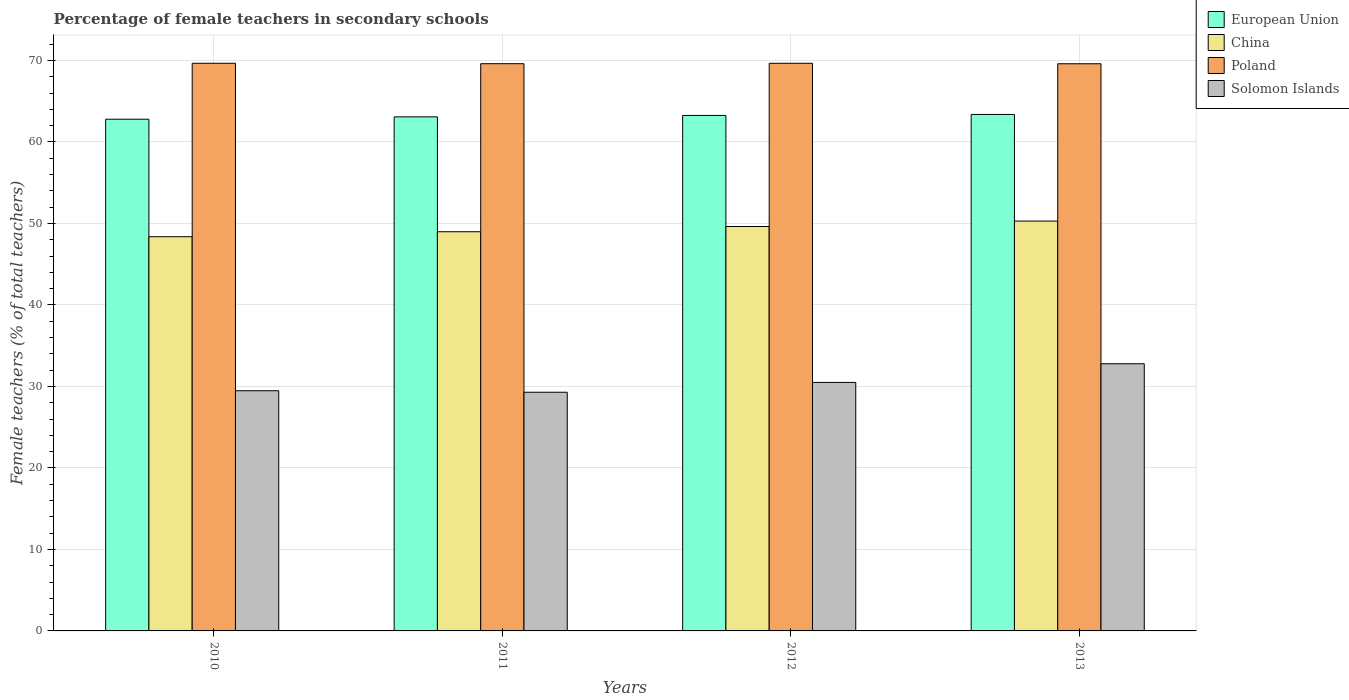How many groups of bars are there?
Give a very brief answer. 4. Are the number of bars per tick equal to the number of legend labels?
Offer a very short reply. Yes. Are the number of bars on each tick of the X-axis equal?
Offer a very short reply. Yes. How many bars are there on the 4th tick from the left?
Your answer should be very brief. 4. How many bars are there on the 2nd tick from the right?
Provide a short and direct response. 4. What is the label of the 3rd group of bars from the left?
Make the answer very short. 2012. In how many cases, is the number of bars for a given year not equal to the number of legend labels?
Your response must be concise. 0. What is the percentage of female teachers in European Union in 2012?
Your response must be concise. 63.25. Across all years, what is the maximum percentage of female teachers in Poland?
Give a very brief answer. 69.65. Across all years, what is the minimum percentage of female teachers in European Union?
Offer a terse response. 62.78. What is the total percentage of female teachers in Solomon Islands in the graph?
Keep it short and to the point. 122.03. What is the difference between the percentage of female teachers in China in 2011 and that in 2012?
Your answer should be compact. -0.64. What is the difference between the percentage of female teachers in Solomon Islands in 2011 and the percentage of female teachers in European Union in 2013?
Provide a short and direct response. -34.08. What is the average percentage of female teachers in European Union per year?
Ensure brevity in your answer.  63.12. In the year 2013, what is the difference between the percentage of female teachers in Poland and percentage of female teachers in Solomon Islands?
Make the answer very short. 36.81. What is the ratio of the percentage of female teachers in European Union in 2011 to that in 2012?
Give a very brief answer. 1. Is the percentage of female teachers in Poland in 2010 less than that in 2011?
Give a very brief answer. No. Is the difference between the percentage of female teachers in Poland in 2010 and 2013 greater than the difference between the percentage of female teachers in Solomon Islands in 2010 and 2013?
Give a very brief answer. Yes. What is the difference between the highest and the second highest percentage of female teachers in Solomon Islands?
Ensure brevity in your answer.  2.29. What is the difference between the highest and the lowest percentage of female teachers in Solomon Islands?
Your response must be concise. 3.5. In how many years, is the percentage of female teachers in China greater than the average percentage of female teachers in China taken over all years?
Keep it short and to the point. 2. What does the 2nd bar from the left in 2010 represents?
Give a very brief answer. China. How many bars are there?
Provide a short and direct response. 16. What is the difference between two consecutive major ticks on the Y-axis?
Your response must be concise. 10. Are the values on the major ticks of Y-axis written in scientific E-notation?
Make the answer very short. No. What is the title of the graph?
Your answer should be compact. Percentage of female teachers in secondary schools. What is the label or title of the X-axis?
Provide a short and direct response. Years. What is the label or title of the Y-axis?
Provide a short and direct response. Female teachers (% of total teachers). What is the Female teachers (% of total teachers) of European Union in 2010?
Your answer should be compact. 62.78. What is the Female teachers (% of total teachers) of China in 2010?
Provide a succinct answer. 48.37. What is the Female teachers (% of total teachers) of Poland in 2010?
Your response must be concise. 69.65. What is the Female teachers (% of total teachers) in Solomon Islands in 2010?
Offer a very short reply. 29.47. What is the Female teachers (% of total teachers) in European Union in 2011?
Offer a terse response. 63.07. What is the Female teachers (% of total teachers) of China in 2011?
Provide a short and direct response. 48.98. What is the Female teachers (% of total teachers) in Poland in 2011?
Your answer should be very brief. 69.6. What is the Female teachers (% of total teachers) of Solomon Islands in 2011?
Offer a very short reply. 29.29. What is the Female teachers (% of total teachers) in European Union in 2012?
Make the answer very short. 63.25. What is the Female teachers (% of total teachers) of China in 2012?
Your answer should be compact. 49.62. What is the Female teachers (% of total teachers) of Poland in 2012?
Ensure brevity in your answer.  69.65. What is the Female teachers (% of total teachers) of Solomon Islands in 2012?
Give a very brief answer. 30.49. What is the Female teachers (% of total teachers) of European Union in 2013?
Ensure brevity in your answer.  63.37. What is the Female teachers (% of total teachers) in China in 2013?
Make the answer very short. 50.28. What is the Female teachers (% of total teachers) in Poland in 2013?
Keep it short and to the point. 69.59. What is the Female teachers (% of total teachers) in Solomon Islands in 2013?
Make the answer very short. 32.78. Across all years, what is the maximum Female teachers (% of total teachers) of European Union?
Ensure brevity in your answer.  63.37. Across all years, what is the maximum Female teachers (% of total teachers) in China?
Your response must be concise. 50.28. Across all years, what is the maximum Female teachers (% of total teachers) of Poland?
Give a very brief answer. 69.65. Across all years, what is the maximum Female teachers (% of total teachers) in Solomon Islands?
Keep it short and to the point. 32.78. Across all years, what is the minimum Female teachers (% of total teachers) in European Union?
Your response must be concise. 62.78. Across all years, what is the minimum Female teachers (% of total teachers) of China?
Your answer should be compact. 48.37. Across all years, what is the minimum Female teachers (% of total teachers) of Poland?
Keep it short and to the point. 69.59. Across all years, what is the minimum Female teachers (% of total teachers) of Solomon Islands?
Keep it short and to the point. 29.29. What is the total Female teachers (% of total teachers) of European Union in the graph?
Ensure brevity in your answer.  252.47. What is the total Female teachers (% of total teachers) of China in the graph?
Provide a short and direct response. 197.25. What is the total Female teachers (% of total teachers) of Poland in the graph?
Ensure brevity in your answer.  278.49. What is the total Female teachers (% of total teachers) in Solomon Islands in the graph?
Offer a terse response. 122.03. What is the difference between the Female teachers (% of total teachers) in European Union in 2010 and that in 2011?
Ensure brevity in your answer.  -0.29. What is the difference between the Female teachers (% of total teachers) of China in 2010 and that in 2011?
Your response must be concise. -0.61. What is the difference between the Female teachers (% of total teachers) in Poland in 2010 and that in 2011?
Provide a succinct answer. 0.05. What is the difference between the Female teachers (% of total teachers) in Solomon Islands in 2010 and that in 2011?
Provide a succinct answer. 0.18. What is the difference between the Female teachers (% of total teachers) in European Union in 2010 and that in 2012?
Make the answer very short. -0.46. What is the difference between the Female teachers (% of total teachers) in China in 2010 and that in 2012?
Your answer should be very brief. -1.25. What is the difference between the Female teachers (% of total teachers) of Poland in 2010 and that in 2012?
Your answer should be compact. 0. What is the difference between the Female teachers (% of total teachers) of Solomon Islands in 2010 and that in 2012?
Provide a short and direct response. -1.02. What is the difference between the Female teachers (% of total teachers) in European Union in 2010 and that in 2013?
Your answer should be compact. -0.59. What is the difference between the Female teachers (% of total teachers) of China in 2010 and that in 2013?
Provide a short and direct response. -1.92. What is the difference between the Female teachers (% of total teachers) in Poland in 2010 and that in 2013?
Your answer should be compact. 0.06. What is the difference between the Female teachers (% of total teachers) of Solomon Islands in 2010 and that in 2013?
Offer a very short reply. -3.31. What is the difference between the Female teachers (% of total teachers) of European Union in 2011 and that in 2012?
Offer a very short reply. -0.17. What is the difference between the Female teachers (% of total teachers) of China in 2011 and that in 2012?
Give a very brief answer. -0.64. What is the difference between the Female teachers (% of total teachers) of Poland in 2011 and that in 2012?
Make the answer very short. -0.05. What is the difference between the Female teachers (% of total teachers) in Solomon Islands in 2011 and that in 2012?
Offer a terse response. -1.21. What is the difference between the Female teachers (% of total teachers) of European Union in 2011 and that in 2013?
Offer a terse response. -0.3. What is the difference between the Female teachers (% of total teachers) in China in 2011 and that in 2013?
Your answer should be compact. -1.31. What is the difference between the Female teachers (% of total teachers) in Poland in 2011 and that in 2013?
Your response must be concise. 0.01. What is the difference between the Female teachers (% of total teachers) of Solomon Islands in 2011 and that in 2013?
Your response must be concise. -3.5. What is the difference between the Female teachers (% of total teachers) of European Union in 2012 and that in 2013?
Your response must be concise. -0.12. What is the difference between the Female teachers (% of total teachers) of China in 2012 and that in 2013?
Your answer should be very brief. -0.67. What is the difference between the Female teachers (% of total teachers) in Poland in 2012 and that in 2013?
Your response must be concise. 0.06. What is the difference between the Female teachers (% of total teachers) of Solomon Islands in 2012 and that in 2013?
Offer a very short reply. -2.29. What is the difference between the Female teachers (% of total teachers) of European Union in 2010 and the Female teachers (% of total teachers) of China in 2011?
Offer a terse response. 13.8. What is the difference between the Female teachers (% of total teachers) in European Union in 2010 and the Female teachers (% of total teachers) in Poland in 2011?
Keep it short and to the point. -6.81. What is the difference between the Female teachers (% of total teachers) in European Union in 2010 and the Female teachers (% of total teachers) in Solomon Islands in 2011?
Make the answer very short. 33.5. What is the difference between the Female teachers (% of total teachers) in China in 2010 and the Female teachers (% of total teachers) in Poland in 2011?
Provide a succinct answer. -21.23. What is the difference between the Female teachers (% of total teachers) of China in 2010 and the Female teachers (% of total teachers) of Solomon Islands in 2011?
Give a very brief answer. 19.08. What is the difference between the Female teachers (% of total teachers) of Poland in 2010 and the Female teachers (% of total teachers) of Solomon Islands in 2011?
Give a very brief answer. 40.36. What is the difference between the Female teachers (% of total teachers) in European Union in 2010 and the Female teachers (% of total teachers) in China in 2012?
Offer a very short reply. 13.16. What is the difference between the Female teachers (% of total teachers) of European Union in 2010 and the Female teachers (% of total teachers) of Poland in 2012?
Ensure brevity in your answer.  -6.87. What is the difference between the Female teachers (% of total teachers) of European Union in 2010 and the Female teachers (% of total teachers) of Solomon Islands in 2012?
Offer a terse response. 32.29. What is the difference between the Female teachers (% of total teachers) in China in 2010 and the Female teachers (% of total teachers) in Poland in 2012?
Your response must be concise. -21.28. What is the difference between the Female teachers (% of total teachers) of China in 2010 and the Female teachers (% of total teachers) of Solomon Islands in 2012?
Your response must be concise. 17.88. What is the difference between the Female teachers (% of total teachers) of Poland in 2010 and the Female teachers (% of total teachers) of Solomon Islands in 2012?
Keep it short and to the point. 39.16. What is the difference between the Female teachers (% of total teachers) of European Union in 2010 and the Female teachers (% of total teachers) of China in 2013?
Give a very brief answer. 12.5. What is the difference between the Female teachers (% of total teachers) of European Union in 2010 and the Female teachers (% of total teachers) of Poland in 2013?
Your answer should be compact. -6.81. What is the difference between the Female teachers (% of total teachers) in European Union in 2010 and the Female teachers (% of total teachers) in Solomon Islands in 2013?
Offer a very short reply. 30. What is the difference between the Female teachers (% of total teachers) in China in 2010 and the Female teachers (% of total teachers) in Poland in 2013?
Provide a short and direct response. -21.22. What is the difference between the Female teachers (% of total teachers) of China in 2010 and the Female teachers (% of total teachers) of Solomon Islands in 2013?
Your response must be concise. 15.59. What is the difference between the Female teachers (% of total teachers) of Poland in 2010 and the Female teachers (% of total teachers) of Solomon Islands in 2013?
Provide a succinct answer. 36.87. What is the difference between the Female teachers (% of total teachers) in European Union in 2011 and the Female teachers (% of total teachers) in China in 2012?
Give a very brief answer. 13.45. What is the difference between the Female teachers (% of total teachers) of European Union in 2011 and the Female teachers (% of total teachers) of Poland in 2012?
Give a very brief answer. -6.58. What is the difference between the Female teachers (% of total teachers) in European Union in 2011 and the Female teachers (% of total teachers) in Solomon Islands in 2012?
Make the answer very short. 32.58. What is the difference between the Female teachers (% of total teachers) in China in 2011 and the Female teachers (% of total teachers) in Poland in 2012?
Provide a short and direct response. -20.67. What is the difference between the Female teachers (% of total teachers) in China in 2011 and the Female teachers (% of total teachers) in Solomon Islands in 2012?
Your answer should be compact. 18.49. What is the difference between the Female teachers (% of total teachers) of Poland in 2011 and the Female teachers (% of total teachers) of Solomon Islands in 2012?
Offer a very short reply. 39.1. What is the difference between the Female teachers (% of total teachers) in European Union in 2011 and the Female teachers (% of total teachers) in China in 2013?
Offer a terse response. 12.79. What is the difference between the Female teachers (% of total teachers) of European Union in 2011 and the Female teachers (% of total teachers) of Poland in 2013?
Offer a terse response. -6.52. What is the difference between the Female teachers (% of total teachers) in European Union in 2011 and the Female teachers (% of total teachers) in Solomon Islands in 2013?
Make the answer very short. 30.29. What is the difference between the Female teachers (% of total teachers) of China in 2011 and the Female teachers (% of total teachers) of Poland in 2013?
Your answer should be compact. -20.61. What is the difference between the Female teachers (% of total teachers) of China in 2011 and the Female teachers (% of total teachers) of Solomon Islands in 2013?
Your answer should be compact. 16.2. What is the difference between the Female teachers (% of total teachers) of Poland in 2011 and the Female teachers (% of total teachers) of Solomon Islands in 2013?
Provide a short and direct response. 36.81. What is the difference between the Female teachers (% of total teachers) in European Union in 2012 and the Female teachers (% of total teachers) in China in 2013?
Your answer should be very brief. 12.96. What is the difference between the Female teachers (% of total teachers) in European Union in 2012 and the Female teachers (% of total teachers) in Poland in 2013?
Your answer should be very brief. -6.34. What is the difference between the Female teachers (% of total teachers) of European Union in 2012 and the Female teachers (% of total teachers) of Solomon Islands in 2013?
Offer a very short reply. 30.46. What is the difference between the Female teachers (% of total teachers) of China in 2012 and the Female teachers (% of total teachers) of Poland in 2013?
Your response must be concise. -19.97. What is the difference between the Female teachers (% of total teachers) of China in 2012 and the Female teachers (% of total teachers) of Solomon Islands in 2013?
Your answer should be very brief. 16.84. What is the difference between the Female teachers (% of total teachers) of Poland in 2012 and the Female teachers (% of total teachers) of Solomon Islands in 2013?
Your response must be concise. 36.87. What is the average Female teachers (% of total teachers) of European Union per year?
Keep it short and to the point. 63.12. What is the average Female teachers (% of total teachers) in China per year?
Your answer should be very brief. 49.31. What is the average Female teachers (% of total teachers) of Poland per year?
Provide a short and direct response. 69.62. What is the average Female teachers (% of total teachers) in Solomon Islands per year?
Your answer should be compact. 30.51. In the year 2010, what is the difference between the Female teachers (% of total teachers) of European Union and Female teachers (% of total teachers) of China?
Provide a short and direct response. 14.41. In the year 2010, what is the difference between the Female teachers (% of total teachers) of European Union and Female teachers (% of total teachers) of Poland?
Provide a succinct answer. -6.87. In the year 2010, what is the difference between the Female teachers (% of total teachers) in European Union and Female teachers (% of total teachers) in Solomon Islands?
Offer a terse response. 33.31. In the year 2010, what is the difference between the Female teachers (% of total teachers) of China and Female teachers (% of total teachers) of Poland?
Keep it short and to the point. -21.28. In the year 2010, what is the difference between the Female teachers (% of total teachers) in China and Female teachers (% of total teachers) in Solomon Islands?
Offer a terse response. 18.9. In the year 2010, what is the difference between the Female teachers (% of total teachers) of Poland and Female teachers (% of total teachers) of Solomon Islands?
Offer a very short reply. 40.18. In the year 2011, what is the difference between the Female teachers (% of total teachers) in European Union and Female teachers (% of total teachers) in China?
Make the answer very short. 14.09. In the year 2011, what is the difference between the Female teachers (% of total teachers) in European Union and Female teachers (% of total teachers) in Poland?
Your answer should be compact. -6.52. In the year 2011, what is the difference between the Female teachers (% of total teachers) in European Union and Female teachers (% of total teachers) in Solomon Islands?
Provide a succinct answer. 33.79. In the year 2011, what is the difference between the Female teachers (% of total teachers) in China and Female teachers (% of total teachers) in Poland?
Offer a terse response. -20.62. In the year 2011, what is the difference between the Female teachers (% of total teachers) in China and Female teachers (% of total teachers) in Solomon Islands?
Provide a short and direct response. 19.69. In the year 2011, what is the difference between the Female teachers (% of total teachers) of Poland and Female teachers (% of total teachers) of Solomon Islands?
Your response must be concise. 40.31. In the year 2012, what is the difference between the Female teachers (% of total teachers) in European Union and Female teachers (% of total teachers) in China?
Make the answer very short. 13.63. In the year 2012, what is the difference between the Female teachers (% of total teachers) in European Union and Female teachers (% of total teachers) in Poland?
Keep it short and to the point. -6.4. In the year 2012, what is the difference between the Female teachers (% of total teachers) in European Union and Female teachers (% of total teachers) in Solomon Islands?
Give a very brief answer. 32.75. In the year 2012, what is the difference between the Female teachers (% of total teachers) in China and Female teachers (% of total teachers) in Poland?
Give a very brief answer. -20.03. In the year 2012, what is the difference between the Female teachers (% of total teachers) in China and Female teachers (% of total teachers) in Solomon Islands?
Offer a very short reply. 19.13. In the year 2012, what is the difference between the Female teachers (% of total teachers) of Poland and Female teachers (% of total teachers) of Solomon Islands?
Make the answer very short. 39.16. In the year 2013, what is the difference between the Female teachers (% of total teachers) of European Union and Female teachers (% of total teachers) of China?
Provide a succinct answer. 13.09. In the year 2013, what is the difference between the Female teachers (% of total teachers) of European Union and Female teachers (% of total teachers) of Poland?
Ensure brevity in your answer.  -6.22. In the year 2013, what is the difference between the Female teachers (% of total teachers) in European Union and Female teachers (% of total teachers) in Solomon Islands?
Provide a succinct answer. 30.59. In the year 2013, what is the difference between the Female teachers (% of total teachers) in China and Female teachers (% of total teachers) in Poland?
Provide a succinct answer. -19.3. In the year 2013, what is the difference between the Female teachers (% of total teachers) in China and Female teachers (% of total teachers) in Solomon Islands?
Your answer should be compact. 17.5. In the year 2013, what is the difference between the Female teachers (% of total teachers) in Poland and Female teachers (% of total teachers) in Solomon Islands?
Offer a very short reply. 36.81. What is the ratio of the Female teachers (% of total teachers) of China in 2010 to that in 2011?
Your answer should be very brief. 0.99. What is the ratio of the Female teachers (% of total teachers) in European Union in 2010 to that in 2012?
Offer a very short reply. 0.99. What is the ratio of the Female teachers (% of total teachers) in China in 2010 to that in 2012?
Ensure brevity in your answer.  0.97. What is the ratio of the Female teachers (% of total teachers) of Solomon Islands in 2010 to that in 2012?
Provide a short and direct response. 0.97. What is the ratio of the Female teachers (% of total teachers) of European Union in 2010 to that in 2013?
Make the answer very short. 0.99. What is the ratio of the Female teachers (% of total teachers) of China in 2010 to that in 2013?
Your answer should be compact. 0.96. What is the ratio of the Female teachers (% of total teachers) of Poland in 2010 to that in 2013?
Provide a succinct answer. 1. What is the ratio of the Female teachers (% of total teachers) in Solomon Islands in 2010 to that in 2013?
Give a very brief answer. 0.9. What is the ratio of the Female teachers (% of total teachers) in China in 2011 to that in 2012?
Your answer should be very brief. 0.99. What is the ratio of the Female teachers (% of total teachers) of Poland in 2011 to that in 2012?
Give a very brief answer. 1. What is the ratio of the Female teachers (% of total teachers) of Solomon Islands in 2011 to that in 2012?
Provide a succinct answer. 0.96. What is the ratio of the Female teachers (% of total teachers) in European Union in 2011 to that in 2013?
Give a very brief answer. 1. What is the ratio of the Female teachers (% of total teachers) of China in 2011 to that in 2013?
Give a very brief answer. 0.97. What is the ratio of the Female teachers (% of total teachers) of Solomon Islands in 2011 to that in 2013?
Offer a terse response. 0.89. What is the ratio of the Female teachers (% of total teachers) of European Union in 2012 to that in 2013?
Your answer should be compact. 1. What is the ratio of the Female teachers (% of total teachers) of Poland in 2012 to that in 2013?
Provide a short and direct response. 1. What is the ratio of the Female teachers (% of total teachers) in Solomon Islands in 2012 to that in 2013?
Give a very brief answer. 0.93. What is the difference between the highest and the second highest Female teachers (% of total teachers) in European Union?
Offer a very short reply. 0.12. What is the difference between the highest and the second highest Female teachers (% of total teachers) of China?
Keep it short and to the point. 0.67. What is the difference between the highest and the second highest Female teachers (% of total teachers) of Poland?
Ensure brevity in your answer.  0. What is the difference between the highest and the second highest Female teachers (% of total teachers) of Solomon Islands?
Your answer should be very brief. 2.29. What is the difference between the highest and the lowest Female teachers (% of total teachers) in European Union?
Ensure brevity in your answer.  0.59. What is the difference between the highest and the lowest Female teachers (% of total teachers) of China?
Make the answer very short. 1.92. What is the difference between the highest and the lowest Female teachers (% of total teachers) in Poland?
Your answer should be very brief. 0.06. What is the difference between the highest and the lowest Female teachers (% of total teachers) in Solomon Islands?
Your answer should be very brief. 3.5. 